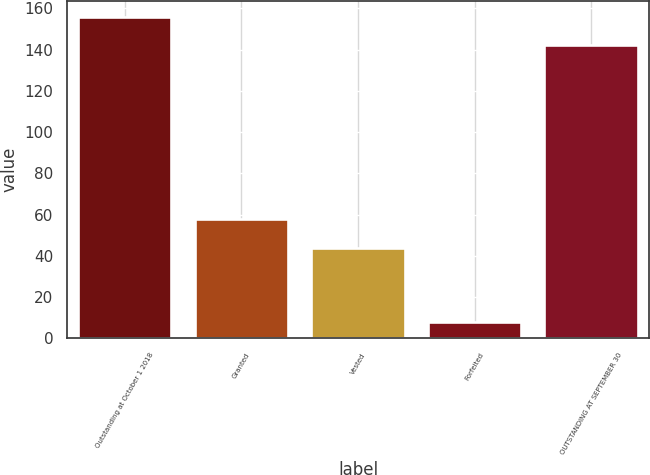<chart> <loc_0><loc_0><loc_500><loc_500><bar_chart><fcel>Outstanding at October 1 2018<fcel>Granted<fcel>Vested<fcel>Forfeited<fcel>OUTSTANDING AT SEPTEMBER 30<nl><fcel>155.8<fcel>57.8<fcel>44<fcel>8<fcel>142<nl></chart> 